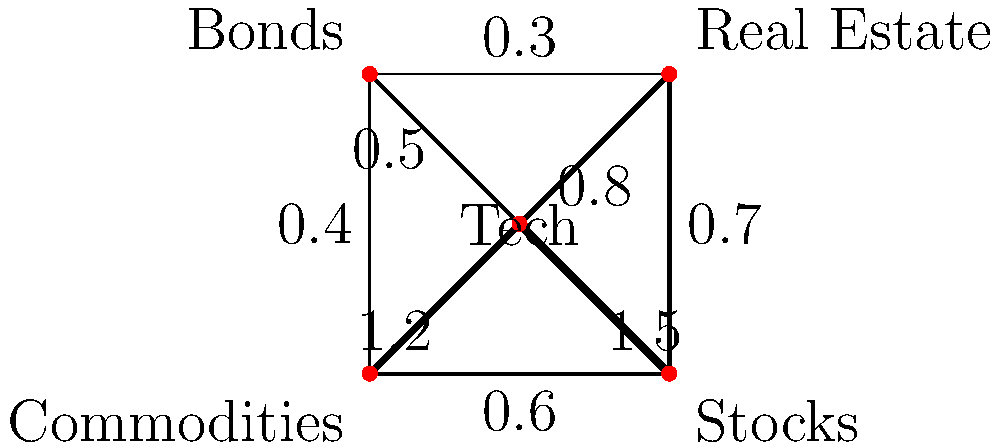In the investment portfolio diversification graph, which asset class has the strongest correlation with the Tech sector, and what investment strategy does this suggest for risk management? To answer this question, we need to analyze the weighted graph representing the investment portfolio diversification:

1. The vertices represent different asset classes: Tech, Real Estate, Bonds, Commodities, and Stocks.
2. The edges represent correlations between asset classes, with thicker lines indicating stronger correlations.
3. The numerical values on the edges represent the correlation coefficients.

Looking at the connections from the Tech vertex:

- Tech to Real Estate: weight 0.8
- Tech to Bonds: weight 0.5
- Tech to Commodities: weight 1.2
- Tech to Stocks: weight 1.5

The strongest correlation is between Tech and Stocks, with a weight of 1.5.

This strong correlation suggests that when the Tech sector performs well, Stocks are likely to perform well too, and vice versa. For risk management, this implies:

1. Diversification benefit between Tech and Stocks might be limited due to their high correlation.
2. To reduce overall portfolio risk, it would be advisable to balance investments in Tech and Stocks with other less correlated assets, such as Bonds (correlation 0.5 with Tech) or Real Estate (correlation 0.8 with Tech).
3. Commodities, with a correlation of 1.2 to Tech, also show a strong relationship and may not provide significant diversification benefits.

The investment strategy suggested for risk management would be to increase allocation to assets less correlated with Tech, particularly Bonds, to balance the high correlation between Tech and Stocks.
Answer: Stocks; increase allocation to less correlated assets, particularly Bonds. 